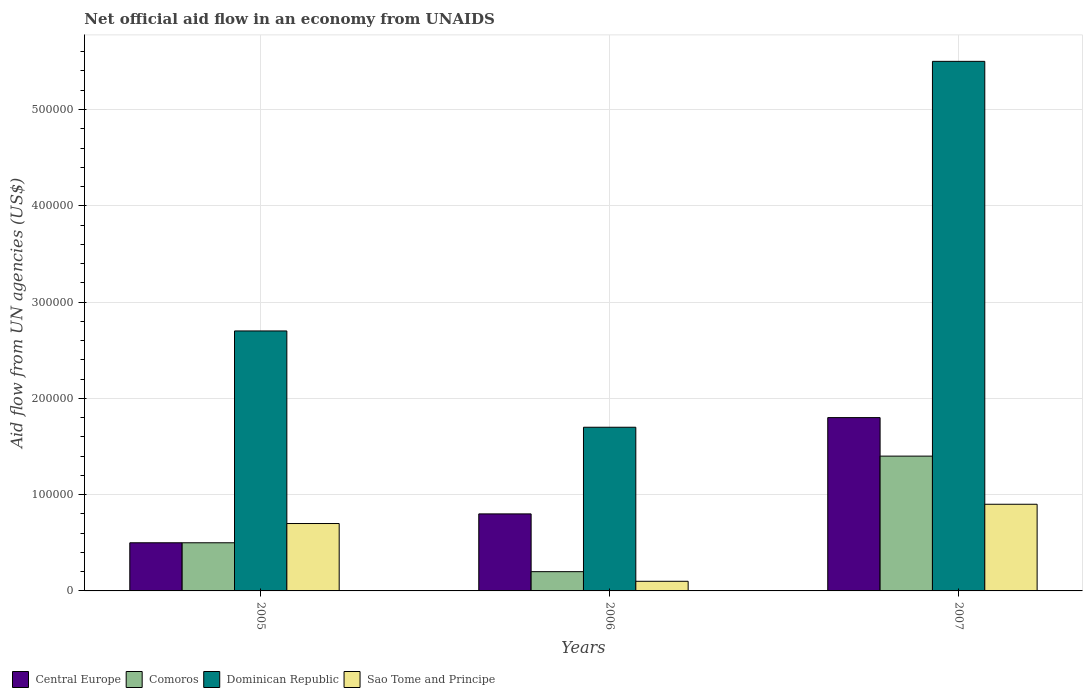Are the number of bars on each tick of the X-axis equal?
Provide a short and direct response. Yes. How many bars are there on the 2nd tick from the left?
Your response must be concise. 4. How many bars are there on the 3rd tick from the right?
Keep it short and to the point. 4. What is the net official aid flow in Comoros in 2005?
Make the answer very short. 5.00e+04. Across all years, what is the minimum net official aid flow in Comoros?
Your answer should be compact. 2.00e+04. What is the total net official aid flow in Comoros in the graph?
Ensure brevity in your answer.  2.10e+05. What is the average net official aid flow in Central Europe per year?
Ensure brevity in your answer.  1.03e+05. In the year 2006, what is the difference between the net official aid flow in Central Europe and net official aid flow in Comoros?
Offer a very short reply. 6.00e+04. In how many years, is the net official aid flow in Dominican Republic greater than 40000 US$?
Ensure brevity in your answer.  3. What is the ratio of the net official aid flow in Central Europe in 2005 to that in 2007?
Give a very brief answer. 0.28. What is the difference between the highest and the second highest net official aid flow in Sao Tome and Principe?
Make the answer very short. 2.00e+04. What is the difference between the highest and the lowest net official aid flow in Central Europe?
Provide a short and direct response. 1.30e+05. In how many years, is the net official aid flow in Dominican Republic greater than the average net official aid flow in Dominican Republic taken over all years?
Keep it short and to the point. 1. Is the sum of the net official aid flow in Sao Tome and Principe in 2006 and 2007 greater than the maximum net official aid flow in Comoros across all years?
Provide a succinct answer. No. What does the 4th bar from the left in 2005 represents?
Ensure brevity in your answer.  Sao Tome and Principe. What does the 2nd bar from the right in 2005 represents?
Keep it short and to the point. Dominican Republic. Is it the case that in every year, the sum of the net official aid flow in Central Europe and net official aid flow in Dominican Republic is greater than the net official aid flow in Sao Tome and Principe?
Your answer should be very brief. Yes. How many bars are there?
Provide a short and direct response. 12. How many years are there in the graph?
Provide a short and direct response. 3. How many legend labels are there?
Your response must be concise. 4. How are the legend labels stacked?
Give a very brief answer. Horizontal. What is the title of the graph?
Your answer should be compact. Net official aid flow in an economy from UNAIDS. What is the label or title of the X-axis?
Your answer should be very brief. Years. What is the label or title of the Y-axis?
Offer a terse response. Aid flow from UN agencies (US$). What is the Aid flow from UN agencies (US$) in Central Europe in 2005?
Offer a terse response. 5.00e+04. What is the Aid flow from UN agencies (US$) of Comoros in 2005?
Offer a very short reply. 5.00e+04. What is the Aid flow from UN agencies (US$) of Sao Tome and Principe in 2005?
Keep it short and to the point. 7.00e+04. What is the Aid flow from UN agencies (US$) in Comoros in 2006?
Give a very brief answer. 2.00e+04. What is the Aid flow from UN agencies (US$) of Dominican Republic in 2006?
Ensure brevity in your answer.  1.70e+05. What is the Aid flow from UN agencies (US$) in Central Europe in 2007?
Your answer should be very brief. 1.80e+05. What is the Aid flow from UN agencies (US$) of Comoros in 2007?
Keep it short and to the point. 1.40e+05. What is the Aid flow from UN agencies (US$) in Dominican Republic in 2007?
Provide a succinct answer. 5.50e+05. Across all years, what is the maximum Aid flow from UN agencies (US$) of Central Europe?
Provide a succinct answer. 1.80e+05. Across all years, what is the maximum Aid flow from UN agencies (US$) of Comoros?
Give a very brief answer. 1.40e+05. Across all years, what is the maximum Aid flow from UN agencies (US$) in Dominican Republic?
Offer a very short reply. 5.50e+05. Across all years, what is the minimum Aid flow from UN agencies (US$) in Comoros?
Give a very brief answer. 2.00e+04. Across all years, what is the minimum Aid flow from UN agencies (US$) in Sao Tome and Principe?
Keep it short and to the point. 10000. What is the total Aid flow from UN agencies (US$) of Comoros in the graph?
Your answer should be very brief. 2.10e+05. What is the total Aid flow from UN agencies (US$) of Dominican Republic in the graph?
Your answer should be compact. 9.90e+05. What is the difference between the Aid flow from UN agencies (US$) in Central Europe in 2005 and that in 2006?
Ensure brevity in your answer.  -3.00e+04. What is the difference between the Aid flow from UN agencies (US$) in Comoros in 2005 and that in 2006?
Provide a succinct answer. 3.00e+04. What is the difference between the Aid flow from UN agencies (US$) of Dominican Republic in 2005 and that in 2007?
Offer a terse response. -2.80e+05. What is the difference between the Aid flow from UN agencies (US$) in Sao Tome and Principe in 2005 and that in 2007?
Offer a very short reply. -2.00e+04. What is the difference between the Aid flow from UN agencies (US$) of Dominican Republic in 2006 and that in 2007?
Offer a terse response. -3.80e+05. What is the difference between the Aid flow from UN agencies (US$) in Sao Tome and Principe in 2006 and that in 2007?
Make the answer very short. -8.00e+04. What is the difference between the Aid flow from UN agencies (US$) in Central Europe in 2005 and the Aid flow from UN agencies (US$) in Comoros in 2006?
Offer a very short reply. 3.00e+04. What is the difference between the Aid flow from UN agencies (US$) in Central Europe in 2005 and the Aid flow from UN agencies (US$) in Dominican Republic in 2006?
Your answer should be compact. -1.20e+05. What is the difference between the Aid flow from UN agencies (US$) in Central Europe in 2005 and the Aid flow from UN agencies (US$) in Sao Tome and Principe in 2006?
Make the answer very short. 4.00e+04. What is the difference between the Aid flow from UN agencies (US$) of Central Europe in 2005 and the Aid flow from UN agencies (US$) of Dominican Republic in 2007?
Offer a terse response. -5.00e+05. What is the difference between the Aid flow from UN agencies (US$) of Comoros in 2005 and the Aid flow from UN agencies (US$) of Dominican Republic in 2007?
Your answer should be compact. -5.00e+05. What is the difference between the Aid flow from UN agencies (US$) of Comoros in 2005 and the Aid flow from UN agencies (US$) of Sao Tome and Principe in 2007?
Offer a very short reply. -4.00e+04. What is the difference between the Aid flow from UN agencies (US$) in Dominican Republic in 2005 and the Aid flow from UN agencies (US$) in Sao Tome and Principe in 2007?
Keep it short and to the point. 1.80e+05. What is the difference between the Aid flow from UN agencies (US$) of Central Europe in 2006 and the Aid flow from UN agencies (US$) of Comoros in 2007?
Provide a succinct answer. -6.00e+04. What is the difference between the Aid flow from UN agencies (US$) of Central Europe in 2006 and the Aid flow from UN agencies (US$) of Dominican Republic in 2007?
Give a very brief answer. -4.70e+05. What is the difference between the Aid flow from UN agencies (US$) in Comoros in 2006 and the Aid flow from UN agencies (US$) in Dominican Republic in 2007?
Provide a short and direct response. -5.30e+05. What is the difference between the Aid flow from UN agencies (US$) in Comoros in 2006 and the Aid flow from UN agencies (US$) in Sao Tome and Principe in 2007?
Offer a very short reply. -7.00e+04. What is the average Aid flow from UN agencies (US$) in Central Europe per year?
Offer a very short reply. 1.03e+05. What is the average Aid flow from UN agencies (US$) of Dominican Republic per year?
Give a very brief answer. 3.30e+05. What is the average Aid flow from UN agencies (US$) of Sao Tome and Principe per year?
Provide a succinct answer. 5.67e+04. In the year 2005, what is the difference between the Aid flow from UN agencies (US$) of Central Europe and Aid flow from UN agencies (US$) of Comoros?
Provide a succinct answer. 0. In the year 2005, what is the difference between the Aid flow from UN agencies (US$) in Central Europe and Aid flow from UN agencies (US$) in Sao Tome and Principe?
Your answer should be compact. -2.00e+04. In the year 2005, what is the difference between the Aid flow from UN agencies (US$) in Comoros and Aid flow from UN agencies (US$) in Dominican Republic?
Offer a terse response. -2.20e+05. In the year 2005, what is the difference between the Aid flow from UN agencies (US$) of Dominican Republic and Aid flow from UN agencies (US$) of Sao Tome and Principe?
Give a very brief answer. 2.00e+05. In the year 2006, what is the difference between the Aid flow from UN agencies (US$) of Central Europe and Aid flow from UN agencies (US$) of Comoros?
Keep it short and to the point. 6.00e+04. In the year 2006, what is the difference between the Aid flow from UN agencies (US$) in Central Europe and Aid flow from UN agencies (US$) in Sao Tome and Principe?
Your answer should be very brief. 7.00e+04. In the year 2006, what is the difference between the Aid flow from UN agencies (US$) in Dominican Republic and Aid flow from UN agencies (US$) in Sao Tome and Principe?
Provide a succinct answer. 1.60e+05. In the year 2007, what is the difference between the Aid flow from UN agencies (US$) of Central Europe and Aid flow from UN agencies (US$) of Comoros?
Make the answer very short. 4.00e+04. In the year 2007, what is the difference between the Aid flow from UN agencies (US$) in Central Europe and Aid flow from UN agencies (US$) in Dominican Republic?
Give a very brief answer. -3.70e+05. In the year 2007, what is the difference between the Aid flow from UN agencies (US$) of Central Europe and Aid flow from UN agencies (US$) of Sao Tome and Principe?
Offer a terse response. 9.00e+04. In the year 2007, what is the difference between the Aid flow from UN agencies (US$) in Comoros and Aid flow from UN agencies (US$) in Dominican Republic?
Ensure brevity in your answer.  -4.10e+05. In the year 2007, what is the difference between the Aid flow from UN agencies (US$) in Comoros and Aid flow from UN agencies (US$) in Sao Tome and Principe?
Provide a succinct answer. 5.00e+04. What is the ratio of the Aid flow from UN agencies (US$) in Comoros in 2005 to that in 2006?
Ensure brevity in your answer.  2.5. What is the ratio of the Aid flow from UN agencies (US$) in Dominican Republic in 2005 to that in 2006?
Provide a short and direct response. 1.59. What is the ratio of the Aid flow from UN agencies (US$) in Central Europe in 2005 to that in 2007?
Give a very brief answer. 0.28. What is the ratio of the Aid flow from UN agencies (US$) in Comoros in 2005 to that in 2007?
Provide a short and direct response. 0.36. What is the ratio of the Aid flow from UN agencies (US$) in Dominican Republic in 2005 to that in 2007?
Your answer should be compact. 0.49. What is the ratio of the Aid flow from UN agencies (US$) in Sao Tome and Principe in 2005 to that in 2007?
Your answer should be compact. 0.78. What is the ratio of the Aid flow from UN agencies (US$) in Central Europe in 2006 to that in 2007?
Your answer should be very brief. 0.44. What is the ratio of the Aid flow from UN agencies (US$) in Comoros in 2006 to that in 2007?
Keep it short and to the point. 0.14. What is the ratio of the Aid flow from UN agencies (US$) of Dominican Republic in 2006 to that in 2007?
Provide a succinct answer. 0.31. What is the difference between the highest and the second highest Aid flow from UN agencies (US$) in Dominican Republic?
Keep it short and to the point. 2.80e+05. What is the difference between the highest and the lowest Aid flow from UN agencies (US$) in Dominican Republic?
Ensure brevity in your answer.  3.80e+05. 